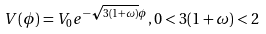<formula> <loc_0><loc_0><loc_500><loc_500>V ( \phi ) = V _ { 0 } e ^ { - \sqrt { 3 ( 1 + \omega ) } \phi } , 0 < 3 ( 1 + \omega ) < 2</formula> 